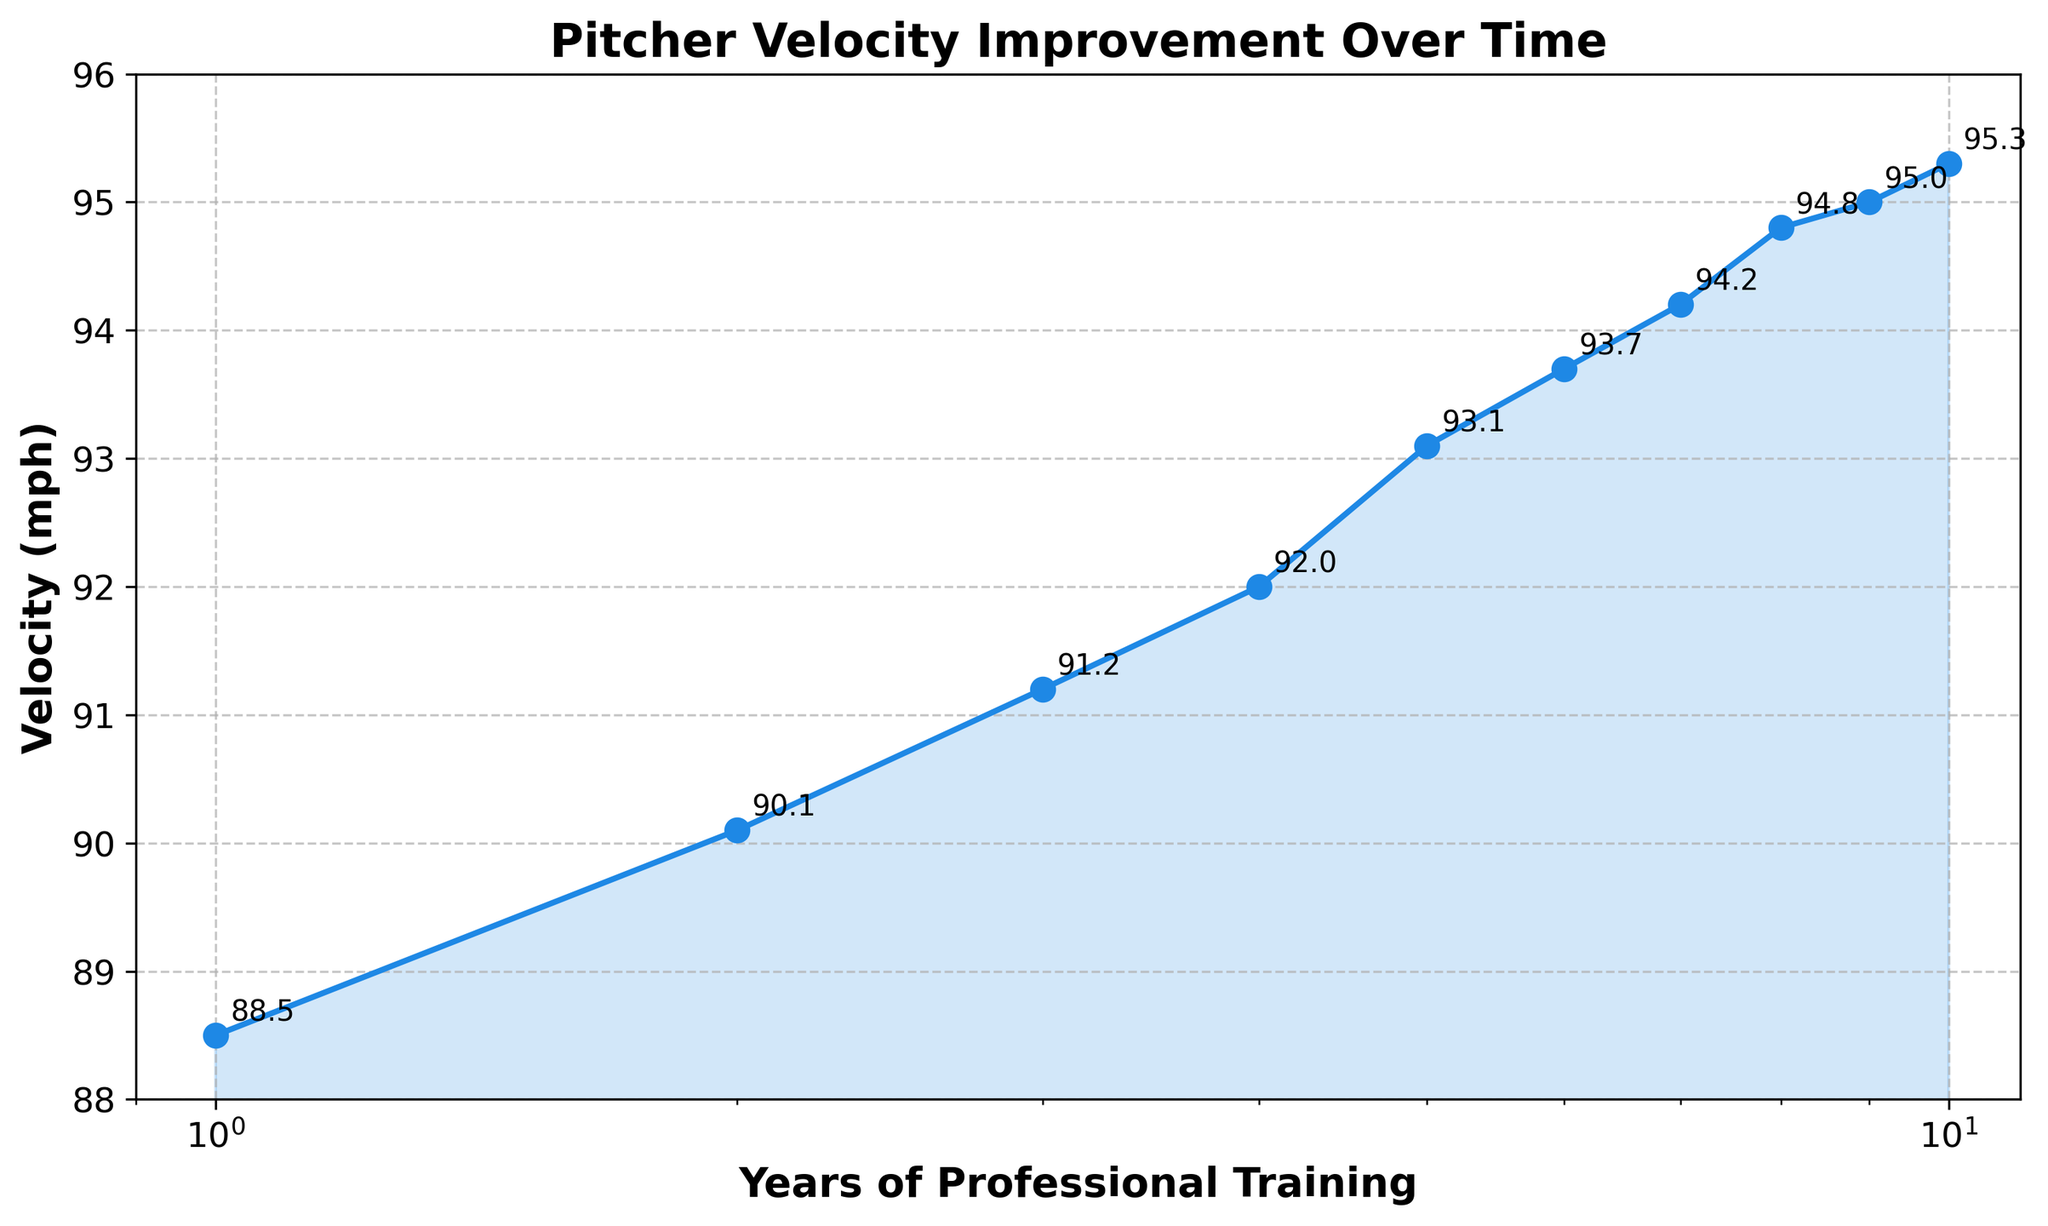What's the title of the plot? The title is displayed at the top center of the plot and summarizes the main content of the graph.
Answer: Pitcher Velocity Improvement Over Time How many data points are plotted on the figure? Each data point represents a year and its corresponding velocity. Count the points on the line plot.
Answer: 10 What is the velocity at year 1? Find the y-value corresponding to the first x-value (year 1) on the plot.
Answer: 88.5 mph What's the difference in velocity between year 5 and year 10? Locate the y-values for years 5 and 10 (93.1 mph and 95.3 mph, respectively) and subtract the former from the latter.
Answer: 2.2 mph During which year is the increase in velocity the largest compared to the previous year? Calculate the differences in velocities between consecutive years and identify the year with the largest increase. The largest increment can be observed from the steeper segment in the plot.
Answer: Between years 1 and 2 What is the general trend of the velocity over the years? Observe the overall shape and direction of the plot’s curve. The line should be consistently increasing, indicating the trend.
Answer: Increasing What is the velocity value at year 4? Identify the corresponding y-value for year 4 on the plot, as annotated or marked by an observation.
Answer: 92.0 mph Describe the progression of the velocities from year 1 to year 10. Summarize the overall trend and notable changes. The initial and final velocities are 88.5 mph and 95.3 mph, respectively, with generally increasing values every year.
Answer: Steady increase from 88.5 mph to 95.3 mph How does the log scale affect the appearance of the year axis? Understand that the x-axis is scaled logarithmically. This impacts how the years are distributed along the axis, providing more space for earlier years and less for later years.
Answer: Compresses later years and expands earlier years Is there any year where the velocity doesn't increase? Check if the velocity values for any two consecutive years are equal. The plot shows a continuous increase each year, confirmed by the absence of flat segments.
Answer: No 